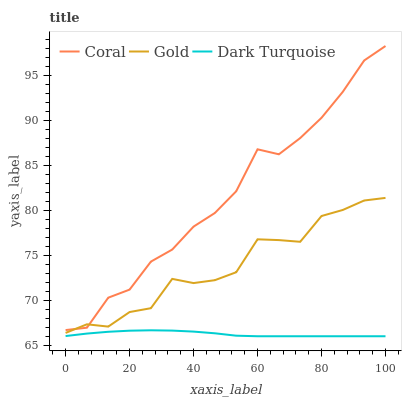Does Dark Turquoise have the minimum area under the curve?
Answer yes or no. Yes. Does Coral have the maximum area under the curve?
Answer yes or no. Yes. Does Gold have the minimum area under the curve?
Answer yes or no. No. Does Gold have the maximum area under the curve?
Answer yes or no. No. Is Dark Turquoise the smoothest?
Answer yes or no. Yes. Is Coral the roughest?
Answer yes or no. Yes. Is Gold the smoothest?
Answer yes or no. No. Is Gold the roughest?
Answer yes or no. No. Does Dark Turquoise have the lowest value?
Answer yes or no. Yes. Does Gold have the lowest value?
Answer yes or no. No. Does Coral have the highest value?
Answer yes or no. Yes. Does Gold have the highest value?
Answer yes or no. No. Is Dark Turquoise less than Coral?
Answer yes or no. Yes. Is Coral greater than Dark Turquoise?
Answer yes or no. Yes. Does Coral intersect Gold?
Answer yes or no. Yes. Is Coral less than Gold?
Answer yes or no. No. Is Coral greater than Gold?
Answer yes or no. No. Does Dark Turquoise intersect Coral?
Answer yes or no. No. 